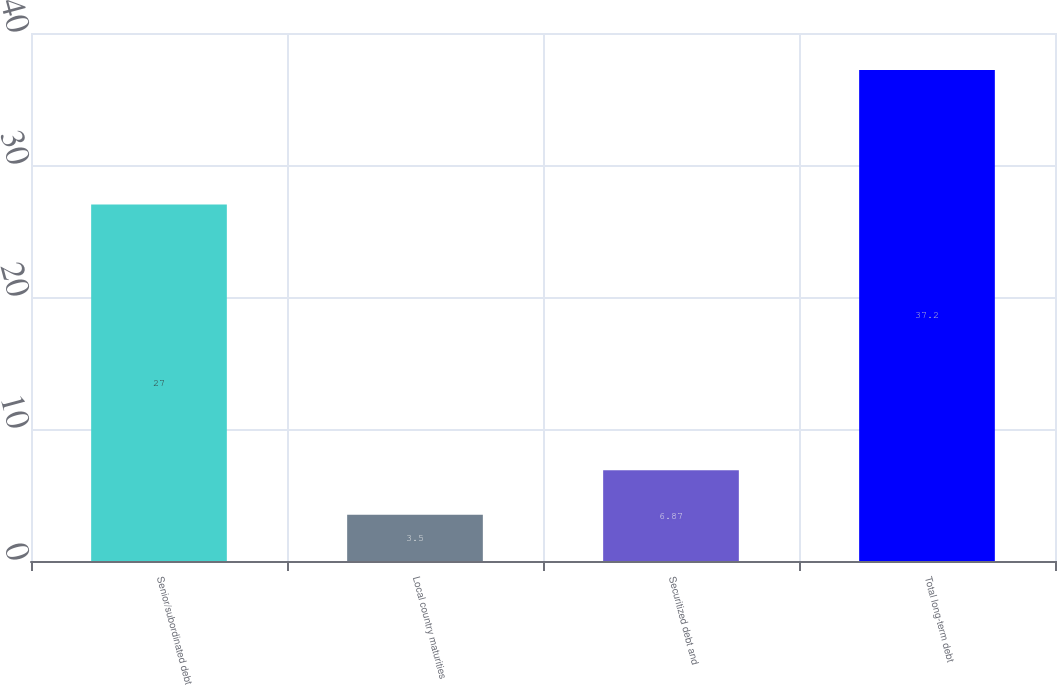<chart> <loc_0><loc_0><loc_500><loc_500><bar_chart><fcel>Senior/subordinated debt<fcel>Local country maturities<fcel>Securitized debt and<fcel>Total long-term debt<nl><fcel>27<fcel>3.5<fcel>6.87<fcel>37.2<nl></chart> 